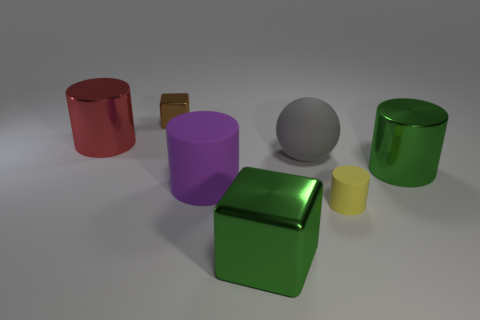Add 3 large red metal cylinders. How many objects exist? 10 Subtract all spheres. How many objects are left? 6 Subtract 0 gray cubes. How many objects are left? 7 Subtract all purple things. Subtract all red objects. How many objects are left? 5 Add 2 small cubes. How many small cubes are left? 3 Add 5 metal cylinders. How many metal cylinders exist? 7 